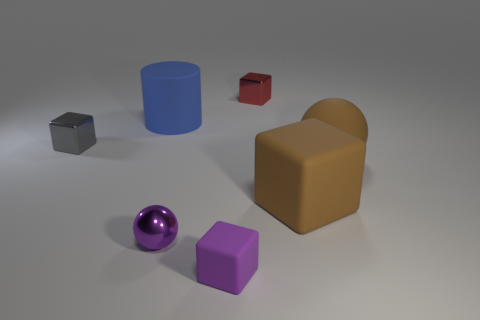Which object appears to be the largest, and what is its texture? The largest object appears to be the blue cylinder on the left side of the image. It has a matte texture, which diffuses light rather than reflecting it sharply like a shiny surface would. 